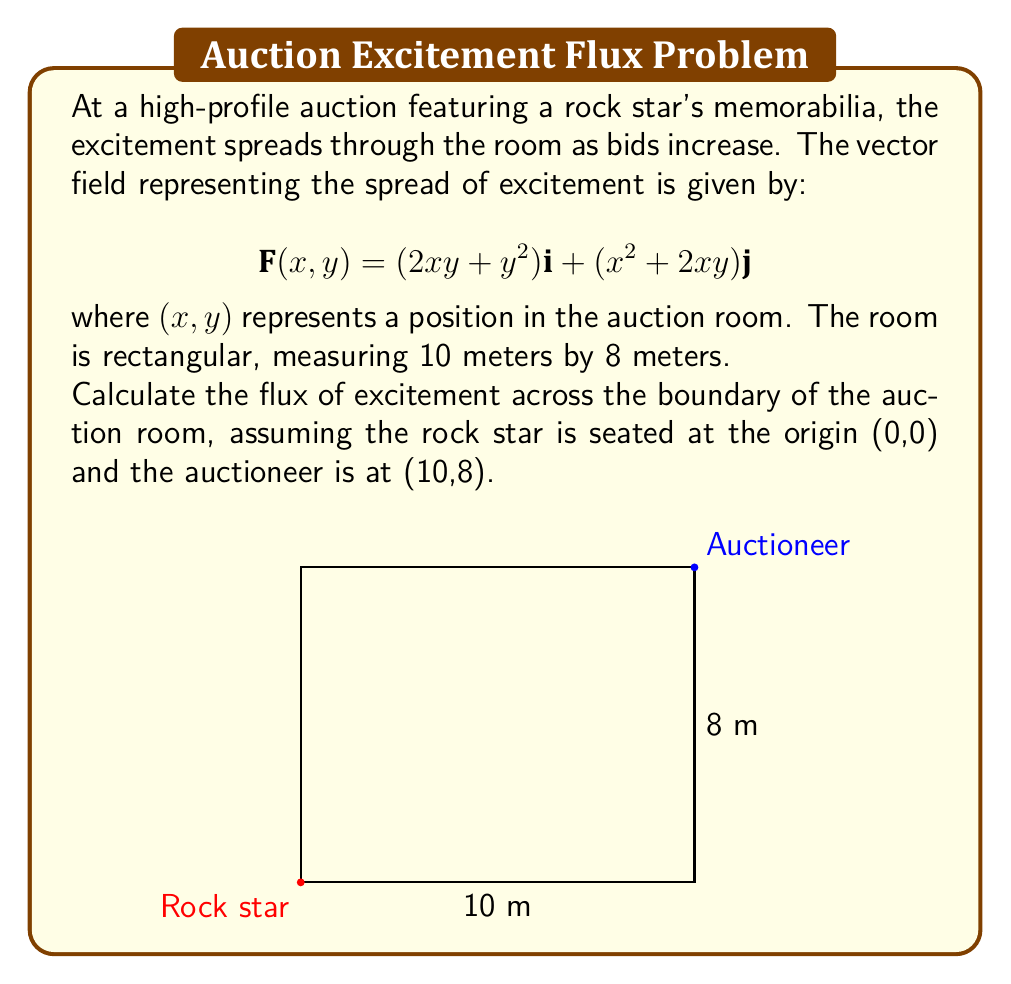Solve this math problem. To solve this problem, we'll use the divergence theorem, which states that the flux of a vector field across a closed surface is equal to the volume integral of the divergence of the field over the region enclosed by the surface.

Step 1: Calculate the divergence of the vector field.
$$\nabla \cdot \mathbf{F} = \frac{\partial}{\partial x}(2xy + y^2) + \frac{\partial}{\partial y}(x^2 + 2xy) = 2y + 2x + 2y = 2x + 4y$$

Step 2: Set up the volume integral for the divergence theorem.
$$\oint_S \mathbf{F} \cdot \mathbf{n} \, dS = \iint_R \nabla \cdot \mathbf{F} \, dA = \iint_R (2x + 4y) \, dA$$

Step 3: Evaluate the double integral over the rectangular region.
$$\int_0^8 \int_0^{10} (2x + 4y) \, dx \, dy$$

Step 4: Solve the inner integral with respect to x.
$$\int_0^8 \left[x^2 + 4xy\right]_0^{10} \, dy = \int_0^8 (100 + 40y) \, dy$$

Step 5: Solve the outer integral with respect to y.
$$\left[100y + 20y^2\right]_0^8 = 800 + 1280 = 2080$$

Therefore, the flux of excitement across the boundary of the auction room is 2080 excitement units.
Answer: 2080 excitement units 